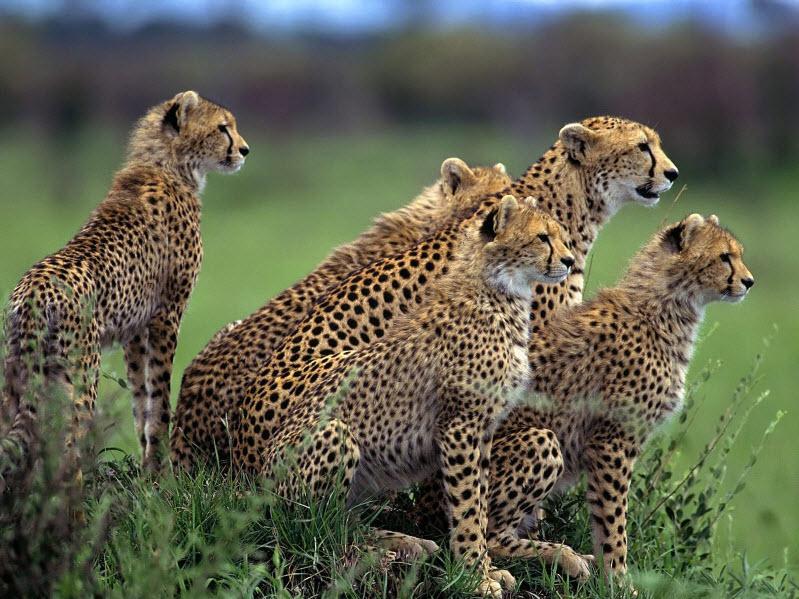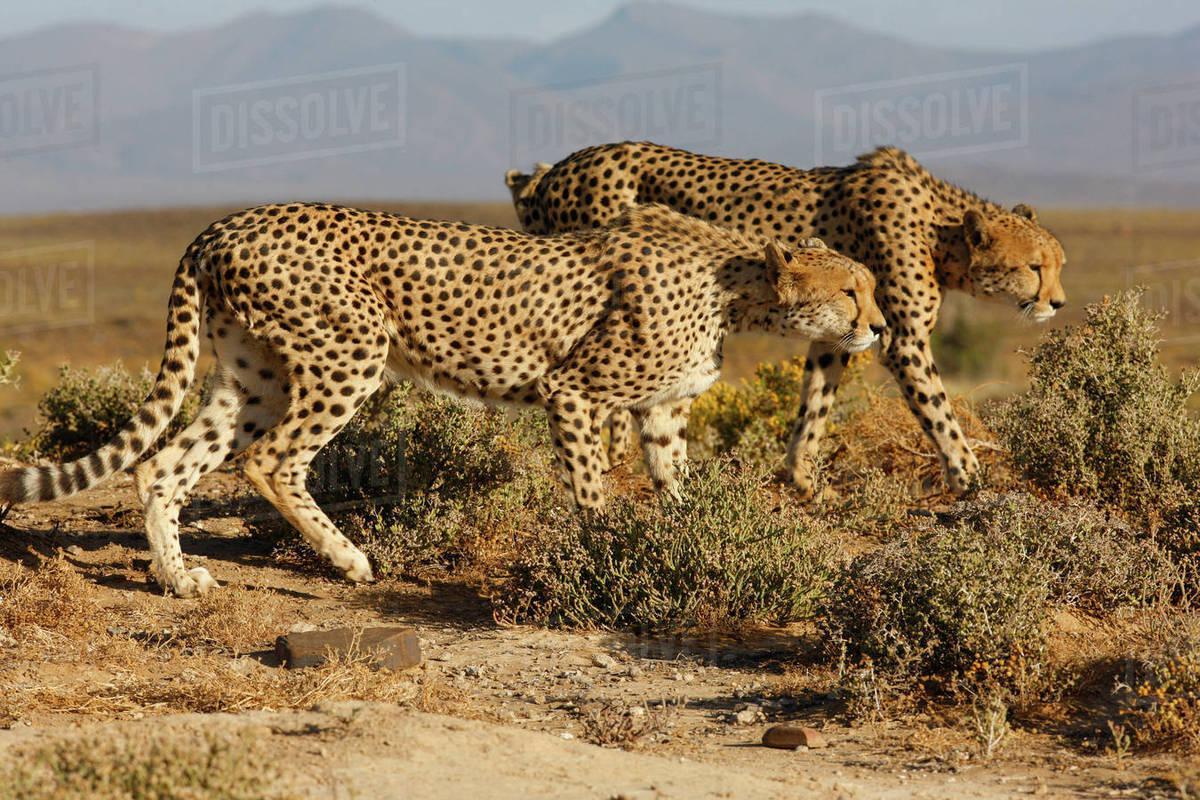The first image is the image on the left, the second image is the image on the right. Evaluate the accuracy of this statement regarding the images: "An image shows five cheetahs with their bodies similarly oriented, pointing right.". Is it true? Answer yes or no. Yes. 